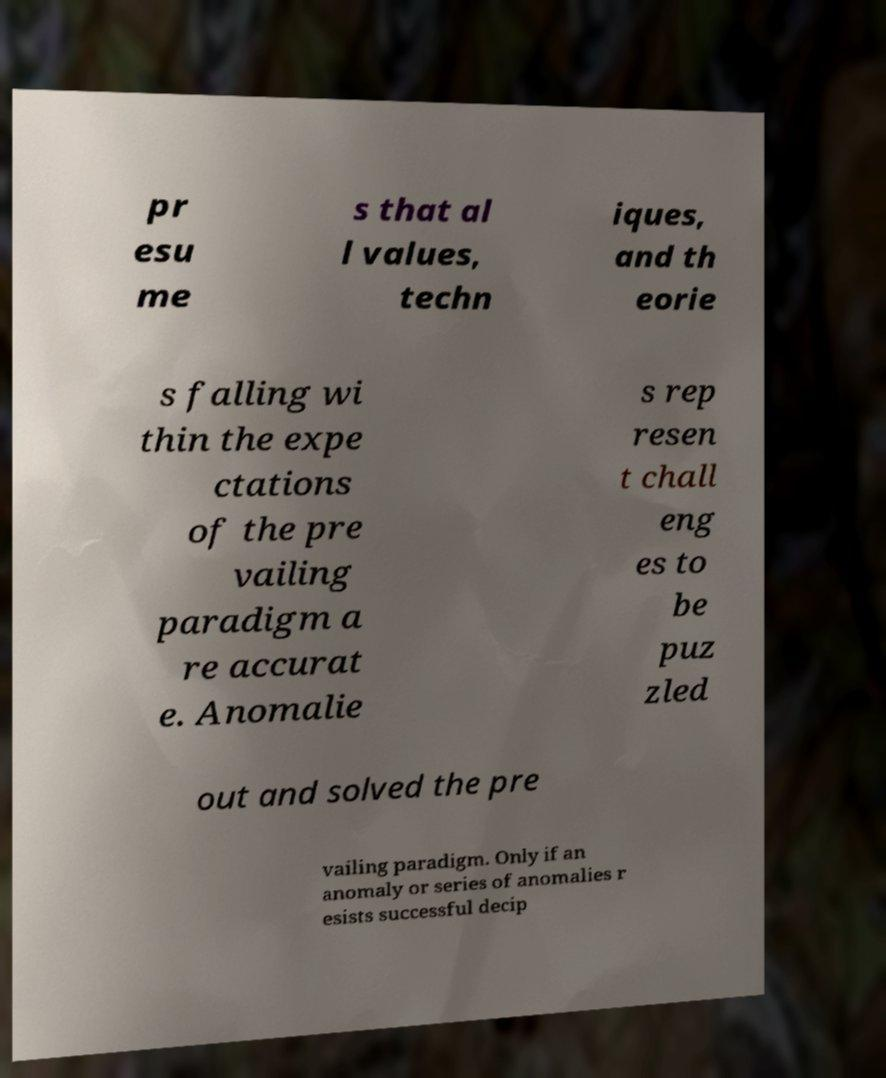I need the written content from this picture converted into text. Can you do that? pr esu me s that al l values, techn iques, and th eorie s falling wi thin the expe ctations of the pre vailing paradigm a re accurat e. Anomalie s rep resen t chall eng es to be puz zled out and solved the pre vailing paradigm. Only if an anomaly or series of anomalies r esists successful decip 